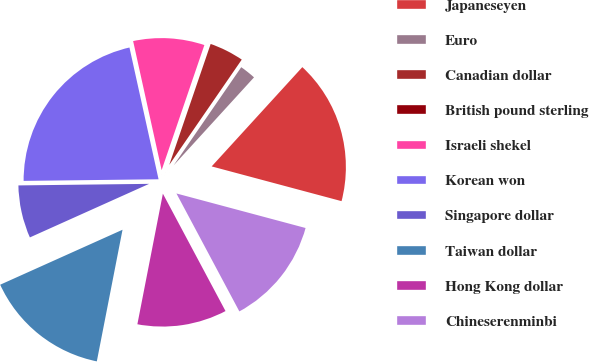Convert chart. <chart><loc_0><loc_0><loc_500><loc_500><pie_chart><fcel>Japaneseyen<fcel>Euro<fcel>Canadian dollar<fcel>British pound sterling<fcel>Israeli shekel<fcel>Korean won<fcel>Singapore dollar<fcel>Taiwan dollar<fcel>Hong Kong dollar<fcel>Chineserenminbi<nl><fcel>17.38%<fcel>2.18%<fcel>4.35%<fcel>0.01%<fcel>8.7%<fcel>21.73%<fcel>6.53%<fcel>15.21%<fcel>10.87%<fcel>13.04%<nl></chart> 